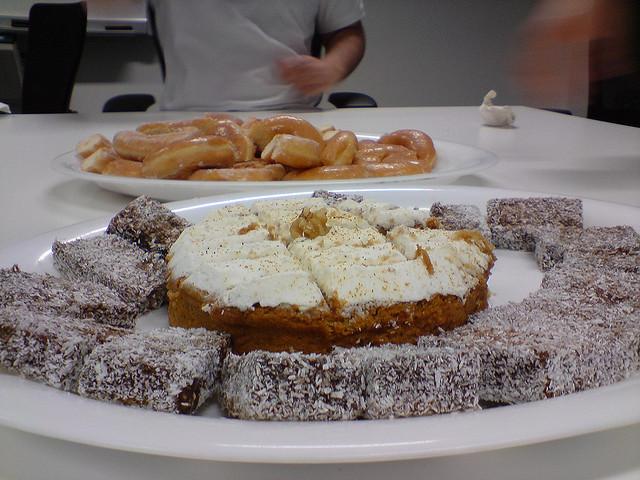What kind of food is this?
Keep it brief. Dessert. What type of food is on the plate?
Short answer required. Cake. What is the hand reaching for?
Write a very short answer. Food. How many plates are there?
Be succinct. 2. Is the food on the plate sweet?
Give a very brief answer. Yes. Does this look good to eat?
Keep it brief. Yes. 